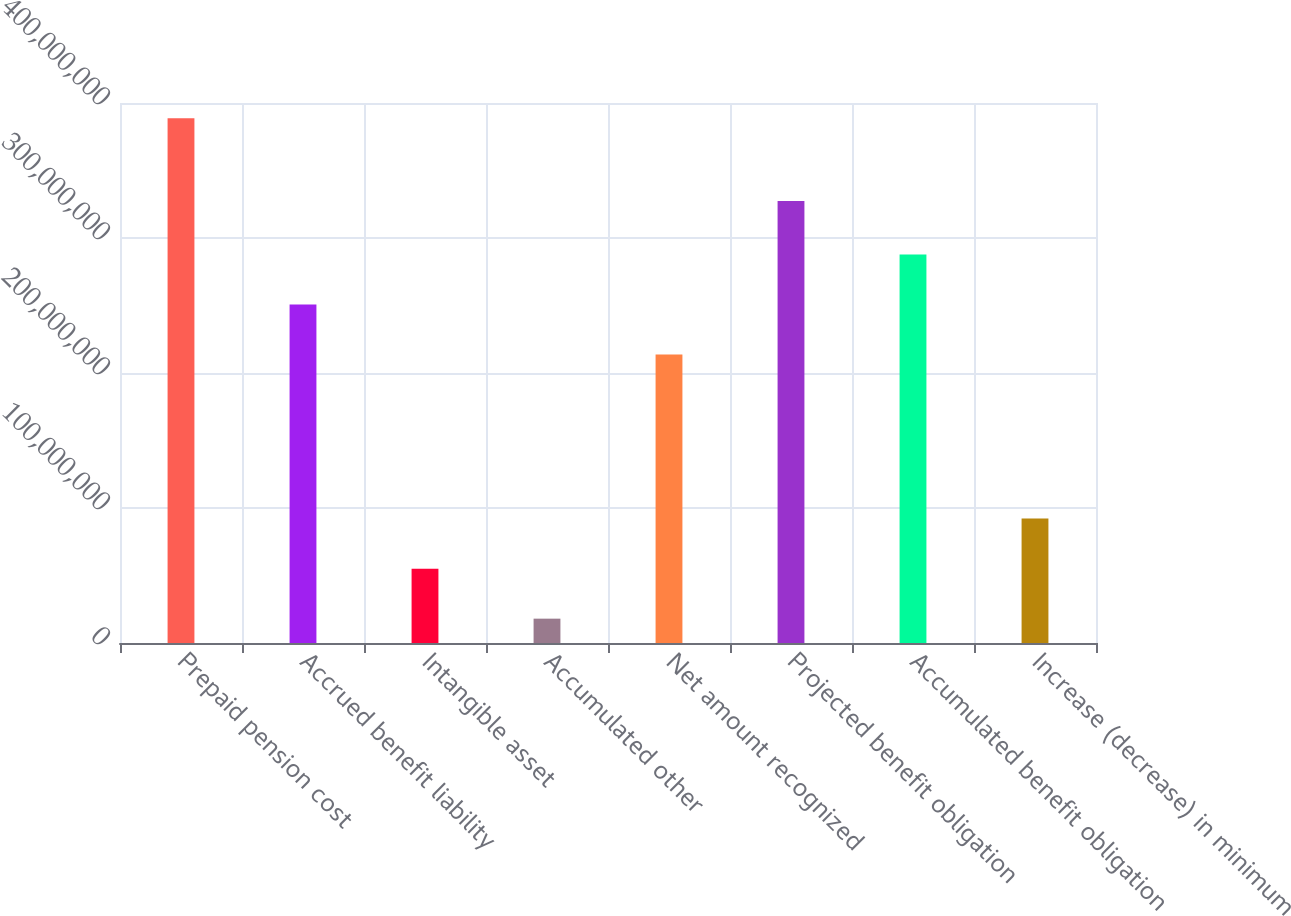Convert chart. <chart><loc_0><loc_0><loc_500><loc_500><bar_chart><fcel>Prepaid pension cost<fcel>Accrued benefit liability<fcel>Intangible asset<fcel>Accumulated other<fcel>Net amount recognized<fcel>Projected benefit obligation<fcel>Accumulated benefit obligation<fcel>Increase (decrease) in minimum<nl><fcel>3.88651e+08<fcel>2.50763e+08<fcel>5.50921e+07<fcel>1.803e+07<fcel>2.13701e+08<fcel>3.2745e+08<fcel>2.87825e+08<fcel>9.21542e+07<nl></chart> 